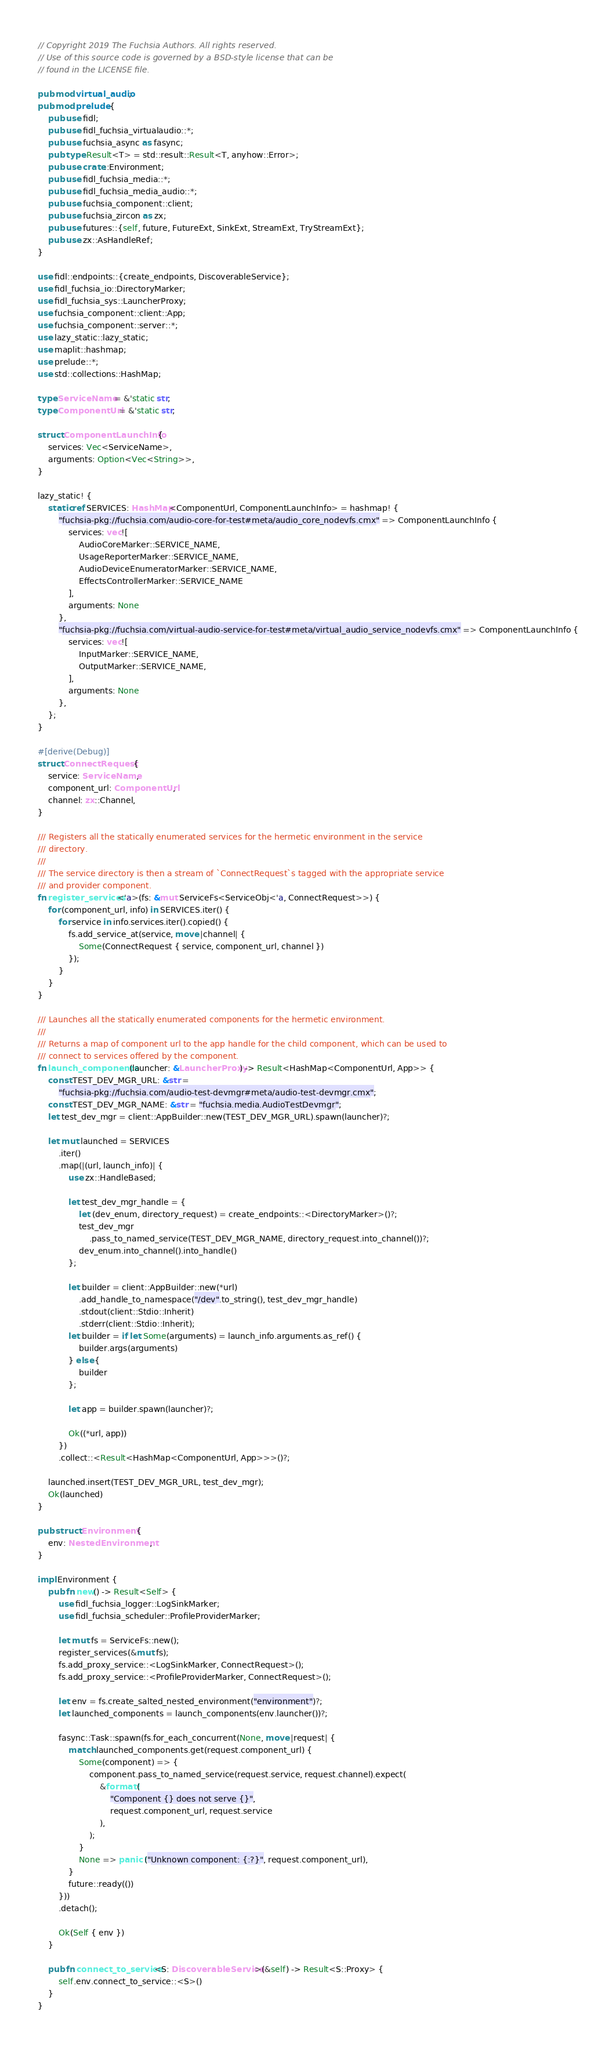Convert code to text. <code><loc_0><loc_0><loc_500><loc_500><_Rust_>// Copyright 2019 The Fuchsia Authors. All rights reserved.
// Use of this source code is governed by a BSD-style license that can be
// found in the LICENSE file.

pub mod virtual_audio;
pub mod prelude {
    pub use fidl;
    pub use fidl_fuchsia_virtualaudio::*;
    pub use fuchsia_async as fasync;
    pub type Result<T> = std::result::Result<T, anyhow::Error>;
    pub use crate::Environment;
    pub use fidl_fuchsia_media::*;
    pub use fidl_fuchsia_media_audio::*;
    pub use fuchsia_component::client;
    pub use fuchsia_zircon as zx;
    pub use futures::{self, future, FutureExt, SinkExt, StreamExt, TryStreamExt};
    pub use zx::AsHandleRef;
}

use fidl::endpoints::{create_endpoints, DiscoverableService};
use fidl_fuchsia_io::DirectoryMarker;
use fidl_fuchsia_sys::LauncherProxy;
use fuchsia_component::client::App;
use fuchsia_component::server::*;
use lazy_static::lazy_static;
use maplit::hashmap;
use prelude::*;
use std::collections::HashMap;

type ServiceName = &'static str;
type ComponentUrl = &'static str;

struct ComponentLaunchInfo {
    services: Vec<ServiceName>,
    arguments: Option<Vec<String>>,
}

lazy_static! {
    static ref SERVICES: HashMap<ComponentUrl, ComponentLaunchInfo> = hashmap! {
        "fuchsia-pkg://fuchsia.com/audio-core-for-test#meta/audio_core_nodevfs.cmx" => ComponentLaunchInfo {
            services: vec![
                AudioCoreMarker::SERVICE_NAME,
                UsageReporterMarker::SERVICE_NAME,
                AudioDeviceEnumeratorMarker::SERVICE_NAME,
                EffectsControllerMarker::SERVICE_NAME
            ],
            arguments: None
        },
        "fuchsia-pkg://fuchsia.com/virtual-audio-service-for-test#meta/virtual_audio_service_nodevfs.cmx" => ComponentLaunchInfo {
            services: vec![
                InputMarker::SERVICE_NAME,
                OutputMarker::SERVICE_NAME,
            ],
            arguments: None
        },
    };
}

#[derive(Debug)]
struct ConnectRequest {
    service: ServiceName,
    component_url: ComponentUrl,
    channel: zx::Channel,
}

/// Registers all the statically enumerated services for the hermetic environment in the service
/// directory.
///
/// The service directory is then a stream of `ConnectRequest`s tagged with the appropriate service
/// and provider component.
fn register_services<'a>(fs: &mut ServiceFs<ServiceObj<'a, ConnectRequest>>) {
    for (component_url, info) in SERVICES.iter() {
        for service in info.services.iter().copied() {
            fs.add_service_at(service, move |channel| {
                Some(ConnectRequest { service, component_url, channel })
            });
        }
    }
}

/// Launches all the statically enumerated components for the hermetic environment.
///
/// Returns a map of component url to the app handle for the child component, which can be used to
/// connect to services offered by the component.
fn launch_components(launcher: &LauncherProxy) -> Result<HashMap<ComponentUrl, App>> {
    const TEST_DEV_MGR_URL: &str =
        "fuchsia-pkg://fuchsia.com/audio-test-devmgr#meta/audio-test-devmgr.cmx";
    const TEST_DEV_MGR_NAME: &str = "fuchsia.media.AudioTestDevmgr";
    let test_dev_mgr = client::AppBuilder::new(TEST_DEV_MGR_URL).spawn(launcher)?;

    let mut launched = SERVICES
        .iter()
        .map(|(url, launch_info)| {
            use zx::HandleBased;

            let test_dev_mgr_handle = {
                let (dev_enum, directory_request) = create_endpoints::<DirectoryMarker>()?;
                test_dev_mgr
                    .pass_to_named_service(TEST_DEV_MGR_NAME, directory_request.into_channel())?;
                dev_enum.into_channel().into_handle()
            };

            let builder = client::AppBuilder::new(*url)
                .add_handle_to_namespace("/dev".to_string(), test_dev_mgr_handle)
                .stdout(client::Stdio::Inherit)
                .stderr(client::Stdio::Inherit);
            let builder = if let Some(arguments) = launch_info.arguments.as_ref() {
                builder.args(arguments)
            } else {
                builder
            };

            let app = builder.spawn(launcher)?;

            Ok((*url, app))
        })
        .collect::<Result<HashMap<ComponentUrl, App>>>()?;

    launched.insert(TEST_DEV_MGR_URL, test_dev_mgr);
    Ok(launched)
}

pub struct Environment {
    env: NestedEnvironment,
}

impl Environment {
    pub fn new() -> Result<Self> {
        use fidl_fuchsia_logger::LogSinkMarker;
        use fidl_fuchsia_scheduler::ProfileProviderMarker;

        let mut fs = ServiceFs::new();
        register_services(&mut fs);
        fs.add_proxy_service::<LogSinkMarker, ConnectRequest>();
        fs.add_proxy_service::<ProfileProviderMarker, ConnectRequest>();

        let env = fs.create_salted_nested_environment("environment")?;
        let launched_components = launch_components(env.launcher())?;

        fasync::Task::spawn(fs.for_each_concurrent(None, move |request| {
            match launched_components.get(request.component_url) {
                Some(component) => {
                    component.pass_to_named_service(request.service, request.channel).expect(
                        &format!(
                            "Component {} does not serve {}",
                            request.component_url, request.service
                        ),
                    );
                }
                None => panic!("Unknown component: {:?}", request.component_url),
            }
            future::ready(())
        }))
        .detach();

        Ok(Self { env })
    }

    pub fn connect_to_service<S: DiscoverableService>(&self) -> Result<S::Proxy> {
        self.env.connect_to_service::<S>()
    }
}
</code> 